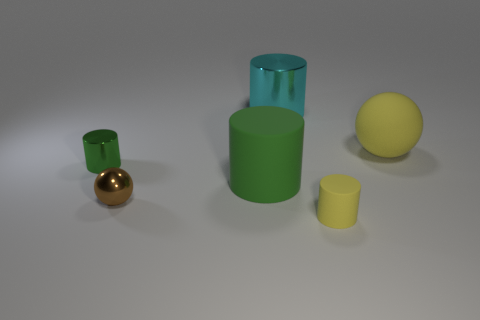Are there more tiny matte cylinders behind the small shiny ball than tiny yellow objects behind the small green object?
Give a very brief answer. No. How many other tiny metal spheres have the same color as the shiny sphere?
Make the answer very short. 0. What is the size of the green object that is the same material as the small brown ball?
Your response must be concise. Small. What number of objects are green cylinders that are behind the green matte cylinder or matte cylinders?
Offer a very short reply. 3. Do the matte cylinder that is to the right of the large cyan metal thing and the tiny sphere have the same color?
Your answer should be very brief. No. What is the size of the green matte object that is the same shape as the cyan metallic object?
Keep it short and to the point. Large. There is a shiny thing that is behind the yellow matte object behind the ball that is to the left of the big yellow thing; what color is it?
Ensure brevity in your answer.  Cyan. Are the tiny yellow object and the tiny green thing made of the same material?
Provide a succinct answer. No. There is a big cylinder right of the green thing that is right of the small metallic cylinder; are there any small matte objects that are to the left of it?
Provide a succinct answer. No. Does the large shiny thing have the same color as the large matte sphere?
Give a very brief answer. No. 